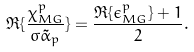<formula> <loc_0><loc_0><loc_500><loc_500>\Re { \{ \frac { \chi ^ { p } _ { M G } } { \sigma \tilde { \alpha } _ { p } } \} } = \frac { \Re { \{ \epsilon ^ { p } _ { M G } \} } + 1 } { 2 } .</formula> 